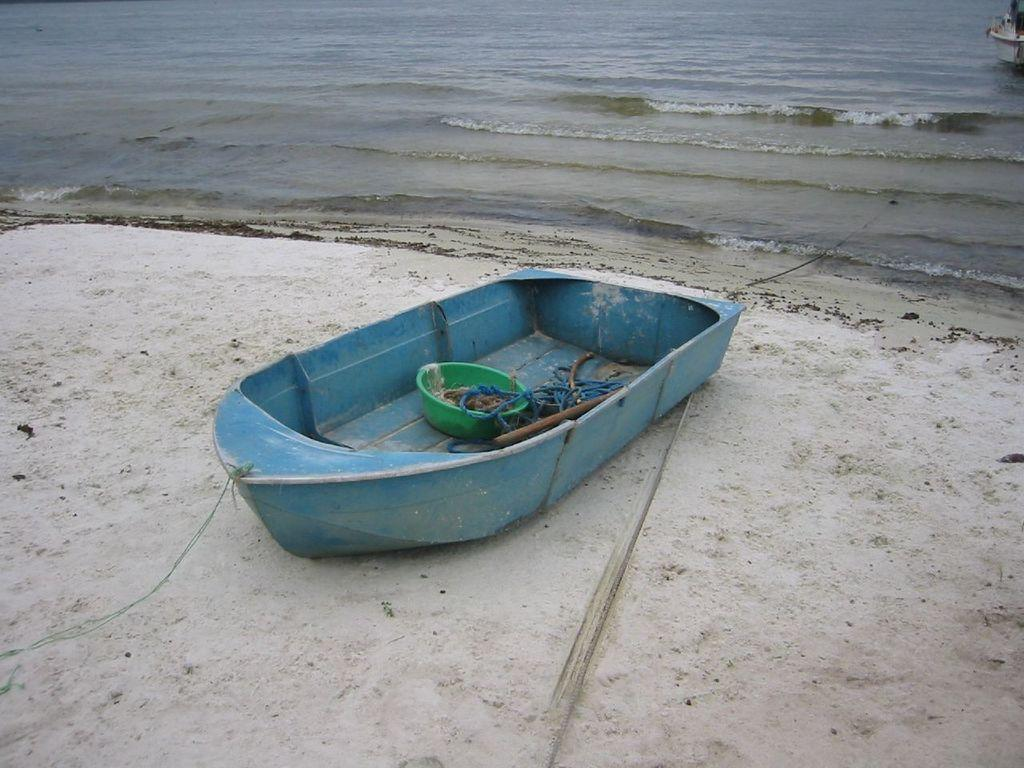What is the main subject of the image? There is a boat in the image. Where is the boat located? The boat is in a beach area. What can be seen in the background of the image? The image has a background of the sea. What type of quince is being used to steer the boat in the image? There is no quince present in the image, and it is not being used to steer the boat. 